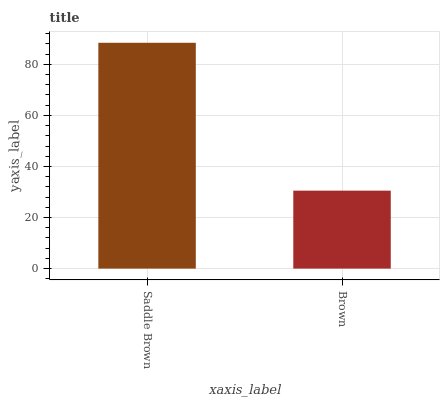Is Brown the minimum?
Answer yes or no. Yes. Is Saddle Brown the maximum?
Answer yes or no. Yes. Is Brown the maximum?
Answer yes or no. No. Is Saddle Brown greater than Brown?
Answer yes or no. Yes. Is Brown less than Saddle Brown?
Answer yes or no. Yes. Is Brown greater than Saddle Brown?
Answer yes or no. No. Is Saddle Brown less than Brown?
Answer yes or no. No. Is Saddle Brown the high median?
Answer yes or no. Yes. Is Brown the low median?
Answer yes or no. Yes. Is Brown the high median?
Answer yes or no. No. Is Saddle Brown the low median?
Answer yes or no. No. 